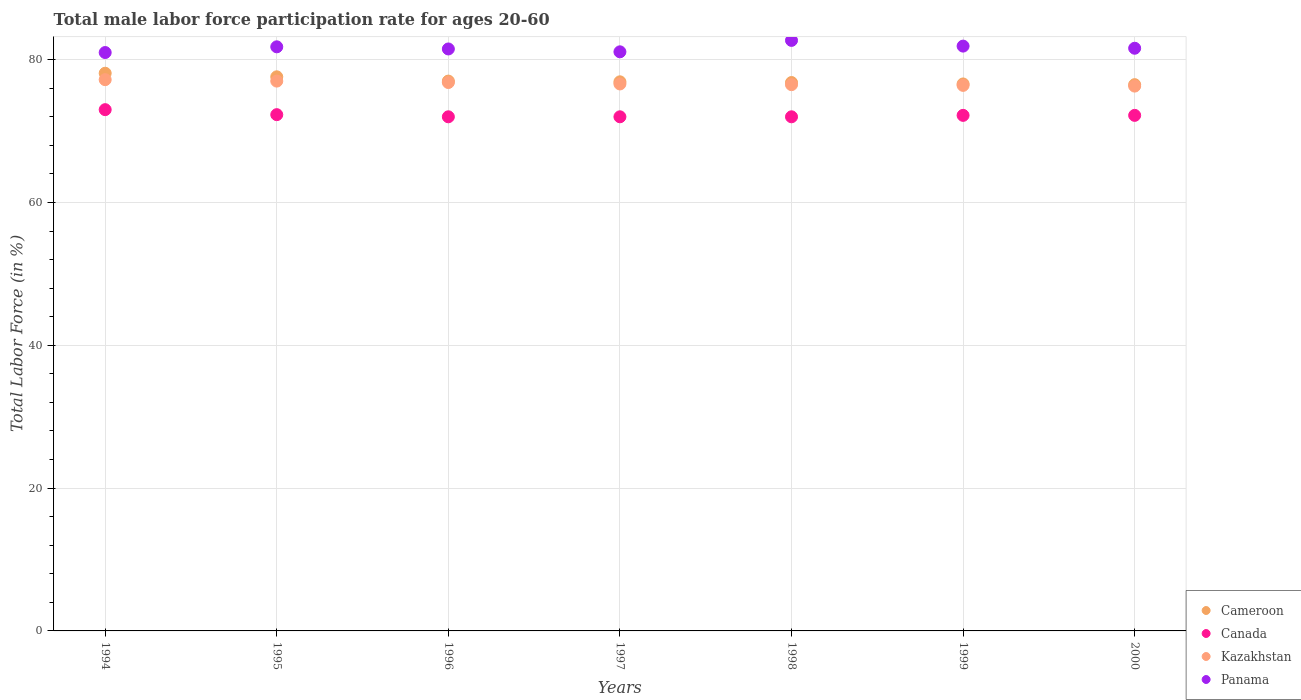How many different coloured dotlines are there?
Provide a short and direct response. 4. What is the male labor force participation rate in Kazakhstan in 1998?
Your response must be concise. 76.5. Across all years, what is the maximum male labor force participation rate in Kazakhstan?
Keep it short and to the point. 77.2. What is the total male labor force participation rate in Kazakhstan in the graph?
Make the answer very short. 536.8. What is the difference between the male labor force participation rate in Panama in 1995 and that in 1999?
Ensure brevity in your answer.  -0.1. What is the difference between the male labor force participation rate in Panama in 1999 and the male labor force participation rate in Kazakhstan in 2000?
Offer a terse response. 5.6. What is the average male labor force participation rate in Panama per year?
Give a very brief answer. 81.66. In the year 1994, what is the difference between the male labor force participation rate in Cameroon and male labor force participation rate in Kazakhstan?
Make the answer very short. 0.9. In how many years, is the male labor force participation rate in Panama greater than 72 %?
Offer a very short reply. 7. What is the ratio of the male labor force participation rate in Panama in 1998 to that in 1999?
Provide a succinct answer. 1.01. Is the male labor force participation rate in Kazakhstan in 1997 less than that in 1999?
Your answer should be compact. No. What is the difference between the highest and the lowest male labor force participation rate in Kazakhstan?
Provide a succinct answer. 0.9. Is the sum of the male labor force participation rate in Cameroon in 1998 and 2000 greater than the maximum male labor force participation rate in Kazakhstan across all years?
Your response must be concise. Yes. Is it the case that in every year, the sum of the male labor force participation rate in Kazakhstan and male labor force participation rate in Panama  is greater than the sum of male labor force participation rate in Cameroon and male labor force participation rate in Canada?
Offer a very short reply. Yes. How many years are there in the graph?
Offer a terse response. 7. What is the difference between two consecutive major ticks on the Y-axis?
Your answer should be very brief. 20. How many legend labels are there?
Offer a terse response. 4. How are the legend labels stacked?
Make the answer very short. Vertical. What is the title of the graph?
Provide a short and direct response. Total male labor force participation rate for ages 20-60. Does "Namibia" appear as one of the legend labels in the graph?
Provide a short and direct response. No. What is the label or title of the X-axis?
Provide a succinct answer. Years. What is the label or title of the Y-axis?
Provide a succinct answer. Total Labor Force (in %). What is the Total Labor Force (in %) of Cameroon in 1994?
Give a very brief answer. 78.1. What is the Total Labor Force (in %) of Canada in 1994?
Provide a succinct answer. 73. What is the Total Labor Force (in %) of Kazakhstan in 1994?
Offer a very short reply. 77.2. What is the Total Labor Force (in %) in Cameroon in 1995?
Provide a succinct answer. 77.6. What is the Total Labor Force (in %) in Canada in 1995?
Provide a short and direct response. 72.3. What is the Total Labor Force (in %) in Kazakhstan in 1995?
Keep it short and to the point. 77. What is the Total Labor Force (in %) in Panama in 1995?
Ensure brevity in your answer.  81.8. What is the Total Labor Force (in %) of Cameroon in 1996?
Your answer should be compact. 77. What is the Total Labor Force (in %) in Kazakhstan in 1996?
Your answer should be compact. 76.8. What is the Total Labor Force (in %) of Panama in 1996?
Offer a terse response. 81.5. What is the Total Labor Force (in %) of Cameroon in 1997?
Ensure brevity in your answer.  76.9. What is the Total Labor Force (in %) in Canada in 1997?
Keep it short and to the point. 72. What is the Total Labor Force (in %) in Kazakhstan in 1997?
Make the answer very short. 76.6. What is the Total Labor Force (in %) in Panama in 1997?
Offer a very short reply. 81.1. What is the Total Labor Force (in %) of Cameroon in 1998?
Your response must be concise. 76.8. What is the Total Labor Force (in %) of Kazakhstan in 1998?
Your answer should be very brief. 76.5. What is the Total Labor Force (in %) of Panama in 1998?
Keep it short and to the point. 82.7. What is the Total Labor Force (in %) in Cameroon in 1999?
Provide a short and direct response. 76.6. What is the Total Labor Force (in %) in Canada in 1999?
Make the answer very short. 72.2. What is the Total Labor Force (in %) in Kazakhstan in 1999?
Your answer should be very brief. 76.4. What is the Total Labor Force (in %) of Panama in 1999?
Give a very brief answer. 81.9. What is the Total Labor Force (in %) in Cameroon in 2000?
Your answer should be very brief. 76.5. What is the Total Labor Force (in %) in Canada in 2000?
Make the answer very short. 72.2. What is the Total Labor Force (in %) of Kazakhstan in 2000?
Your answer should be compact. 76.3. What is the Total Labor Force (in %) of Panama in 2000?
Give a very brief answer. 81.6. Across all years, what is the maximum Total Labor Force (in %) of Cameroon?
Your answer should be compact. 78.1. Across all years, what is the maximum Total Labor Force (in %) in Kazakhstan?
Offer a very short reply. 77.2. Across all years, what is the maximum Total Labor Force (in %) in Panama?
Provide a short and direct response. 82.7. Across all years, what is the minimum Total Labor Force (in %) of Cameroon?
Keep it short and to the point. 76.5. Across all years, what is the minimum Total Labor Force (in %) in Canada?
Provide a succinct answer. 72. Across all years, what is the minimum Total Labor Force (in %) of Kazakhstan?
Your answer should be very brief. 76.3. What is the total Total Labor Force (in %) of Cameroon in the graph?
Ensure brevity in your answer.  539.5. What is the total Total Labor Force (in %) in Canada in the graph?
Provide a short and direct response. 505.7. What is the total Total Labor Force (in %) in Kazakhstan in the graph?
Your answer should be very brief. 536.8. What is the total Total Labor Force (in %) in Panama in the graph?
Give a very brief answer. 571.6. What is the difference between the Total Labor Force (in %) of Cameroon in 1994 and that in 1995?
Give a very brief answer. 0.5. What is the difference between the Total Labor Force (in %) of Kazakhstan in 1994 and that in 1995?
Your response must be concise. 0.2. What is the difference between the Total Labor Force (in %) of Cameroon in 1994 and that in 1996?
Your answer should be compact. 1.1. What is the difference between the Total Labor Force (in %) in Canada in 1994 and that in 1997?
Provide a short and direct response. 1. What is the difference between the Total Labor Force (in %) in Kazakhstan in 1994 and that in 1997?
Your response must be concise. 0.6. What is the difference between the Total Labor Force (in %) of Panama in 1994 and that in 1997?
Keep it short and to the point. -0.1. What is the difference between the Total Labor Force (in %) in Canada in 1994 and that in 1998?
Your answer should be very brief. 1. What is the difference between the Total Labor Force (in %) in Kazakhstan in 1994 and that in 1998?
Your answer should be very brief. 0.7. What is the difference between the Total Labor Force (in %) of Panama in 1994 and that in 1998?
Your answer should be compact. -1.7. What is the difference between the Total Labor Force (in %) of Kazakhstan in 1994 and that in 1999?
Your answer should be very brief. 0.8. What is the difference between the Total Labor Force (in %) in Canada in 1994 and that in 2000?
Your response must be concise. 0.8. What is the difference between the Total Labor Force (in %) of Kazakhstan in 1994 and that in 2000?
Make the answer very short. 0.9. What is the difference between the Total Labor Force (in %) in Cameroon in 1995 and that in 1997?
Your response must be concise. 0.7. What is the difference between the Total Labor Force (in %) in Canada in 1995 and that in 1997?
Give a very brief answer. 0.3. What is the difference between the Total Labor Force (in %) of Kazakhstan in 1995 and that in 1997?
Your response must be concise. 0.4. What is the difference between the Total Labor Force (in %) in Panama in 1995 and that in 1997?
Your answer should be very brief. 0.7. What is the difference between the Total Labor Force (in %) in Canada in 1995 and that in 1998?
Offer a very short reply. 0.3. What is the difference between the Total Labor Force (in %) of Cameroon in 1995 and that in 1999?
Provide a succinct answer. 1. What is the difference between the Total Labor Force (in %) in Canada in 1995 and that in 1999?
Make the answer very short. 0.1. What is the difference between the Total Labor Force (in %) of Panama in 1995 and that in 1999?
Offer a very short reply. -0.1. What is the difference between the Total Labor Force (in %) of Cameroon in 1995 and that in 2000?
Give a very brief answer. 1.1. What is the difference between the Total Labor Force (in %) of Kazakhstan in 1995 and that in 2000?
Your answer should be very brief. 0.7. What is the difference between the Total Labor Force (in %) in Cameroon in 1996 and that in 1997?
Your answer should be compact. 0.1. What is the difference between the Total Labor Force (in %) of Canada in 1996 and that in 1997?
Your answer should be very brief. 0. What is the difference between the Total Labor Force (in %) of Kazakhstan in 1996 and that in 1998?
Ensure brevity in your answer.  0.3. What is the difference between the Total Labor Force (in %) in Panama in 1996 and that in 1998?
Offer a very short reply. -1.2. What is the difference between the Total Labor Force (in %) of Panama in 1996 and that in 1999?
Provide a succinct answer. -0.4. What is the difference between the Total Labor Force (in %) in Cameroon in 1996 and that in 2000?
Provide a short and direct response. 0.5. What is the difference between the Total Labor Force (in %) of Kazakhstan in 1996 and that in 2000?
Keep it short and to the point. 0.5. What is the difference between the Total Labor Force (in %) in Panama in 1996 and that in 2000?
Your answer should be compact. -0.1. What is the difference between the Total Labor Force (in %) of Kazakhstan in 1997 and that in 1998?
Keep it short and to the point. 0.1. What is the difference between the Total Labor Force (in %) in Canada in 1997 and that in 1999?
Keep it short and to the point. -0.2. What is the difference between the Total Labor Force (in %) of Panama in 1997 and that in 1999?
Keep it short and to the point. -0.8. What is the difference between the Total Labor Force (in %) in Cameroon in 1997 and that in 2000?
Offer a very short reply. 0.4. What is the difference between the Total Labor Force (in %) of Canada in 1997 and that in 2000?
Provide a short and direct response. -0.2. What is the difference between the Total Labor Force (in %) of Cameroon in 1998 and that in 1999?
Offer a very short reply. 0.2. What is the difference between the Total Labor Force (in %) of Canada in 1998 and that in 1999?
Your response must be concise. -0.2. What is the difference between the Total Labor Force (in %) in Kazakhstan in 1998 and that in 1999?
Offer a terse response. 0.1. What is the difference between the Total Labor Force (in %) of Cameroon in 1998 and that in 2000?
Give a very brief answer. 0.3. What is the difference between the Total Labor Force (in %) of Canada in 1998 and that in 2000?
Give a very brief answer. -0.2. What is the difference between the Total Labor Force (in %) of Kazakhstan in 1998 and that in 2000?
Make the answer very short. 0.2. What is the difference between the Total Labor Force (in %) in Cameroon in 1999 and that in 2000?
Provide a succinct answer. 0.1. What is the difference between the Total Labor Force (in %) in Canada in 1999 and that in 2000?
Your answer should be very brief. 0. What is the difference between the Total Labor Force (in %) of Panama in 1999 and that in 2000?
Provide a short and direct response. 0.3. What is the difference between the Total Labor Force (in %) of Cameroon in 1994 and the Total Labor Force (in %) of Canada in 1995?
Make the answer very short. 5.8. What is the difference between the Total Labor Force (in %) in Canada in 1994 and the Total Labor Force (in %) in Kazakhstan in 1995?
Make the answer very short. -4. What is the difference between the Total Labor Force (in %) of Kazakhstan in 1994 and the Total Labor Force (in %) of Panama in 1995?
Make the answer very short. -4.6. What is the difference between the Total Labor Force (in %) in Cameroon in 1994 and the Total Labor Force (in %) in Canada in 1996?
Your answer should be very brief. 6.1. What is the difference between the Total Labor Force (in %) in Cameroon in 1994 and the Total Labor Force (in %) in Kazakhstan in 1996?
Your response must be concise. 1.3. What is the difference between the Total Labor Force (in %) in Cameroon in 1994 and the Total Labor Force (in %) in Panama in 1996?
Give a very brief answer. -3.4. What is the difference between the Total Labor Force (in %) in Canada in 1994 and the Total Labor Force (in %) in Panama in 1996?
Make the answer very short. -8.5. What is the difference between the Total Labor Force (in %) in Cameroon in 1994 and the Total Labor Force (in %) in Canada in 1997?
Keep it short and to the point. 6.1. What is the difference between the Total Labor Force (in %) in Canada in 1994 and the Total Labor Force (in %) in Kazakhstan in 1997?
Your answer should be very brief. -3.6. What is the difference between the Total Labor Force (in %) of Canada in 1994 and the Total Labor Force (in %) of Panama in 1997?
Make the answer very short. -8.1. What is the difference between the Total Labor Force (in %) in Cameroon in 1994 and the Total Labor Force (in %) in Kazakhstan in 1998?
Give a very brief answer. 1.6. What is the difference between the Total Labor Force (in %) of Canada in 1994 and the Total Labor Force (in %) of Kazakhstan in 1998?
Give a very brief answer. -3.5. What is the difference between the Total Labor Force (in %) in Canada in 1994 and the Total Labor Force (in %) in Panama in 1998?
Give a very brief answer. -9.7. What is the difference between the Total Labor Force (in %) in Kazakhstan in 1994 and the Total Labor Force (in %) in Panama in 1998?
Make the answer very short. -5.5. What is the difference between the Total Labor Force (in %) in Cameroon in 1994 and the Total Labor Force (in %) in Canada in 1999?
Keep it short and to the point. 5.9. What is the difference between the Total Labor Force (in %) of Cameroon in 1994 and the Total Labor Force (in %) of Kazakhstan in 1999?
Ensure brevity in your answer.  1.7. What is the difference between the Total Labor Force (in %) in Canada in 1994 and the Total Labor Force (in %) in Kazakhstan in 1999?
Ensure brevity in your answer.  -3.4. What is the difference between the Total Labor Force (in %) in Canada in 1994 and the Total Labor Force (in %) in Panama in 1999?
Keep it short and to the point. -8.9. What is the difference between the Total Labor Force (in %) of Kazakhstan in 1994 and the Total Labor Force (in %) of Panama in 1999?
Your answer should be compact. -4.7. What is the difference between the Total Labor Force (in %) in Canada in 1994 and the Total Labor Force (in %) in Kazakhstan in 2000?
Your answer should be compact. -3.3. What is the difference between the Total Labor Force (in %) in Kazakhstan in 1994 and the Total Labor Force (in %) in Panama in 2000?
Your response must be concise. -4.4. What is the difference between the Total Labor Force (in %) in Cameroon in 1995 and the Total Labor Force (in %) in Canada in 1996?
Provide a short and direct response. 5.6. What is the difference between the Total Labor Force (in %) in Cameroon in 1995 and the Total Labor Force (in %) in Kazakhstan in 1996?
Offer a very short reply. 0.8. What is the difference between the Total Labor Force (in %) in Cameroon in 1995 and the Total Labor Force (in %) in Panama in 1996?
Make the answer very short. -3.9. What is the difference between the Total Labor Force (in %) of Canada in 1995 and the Total Labor Force (in %) of Kazakhstan in 1996?
Provide a succinct answer. -4.5. What is the difference between the Total Labor Force (in %) of Canada in 1995 and the Total Labor Force (in %) of Kazakhstan in 1997?
Ensure brevity in your answer.  -4.3. What is the difference between the Total Labor Force (in %) of Canada in 1995 and the Total Labor Force (in %) of Panama in 1997?
Provide a short and direct response. -8.8. What is the difference between the Total Labor Force (in %) of Kazakhstan in 1995 and the Total Labor Force (in %) of Panama in 1997?
Ensure brevity in your answer.  -4.1. What is the difference between the Total Labor Force (in %) of Cameroon in 1995 and the Total Labor Force (in %) of Kazakhstan in 1998?
Provide a succinct answer. 1.1. What is the difference between the Total Labor Force (in %) in Canada in 1995 and the Total Labor Force (in %) in Kazakhstan in 1998?
Provide a short and direct response. -4.2. What is the difference between the Total Labor Force (in %) in Cameroon in 1995 and the Total Labor Force (in %) in Panama in 1999?
Give a very brief answer. -4.3. What is the difference between the Total Labor Force (in %) of Cameroon in 1995 and the Total Labor Force (in %) of Canada in 2000?
Provide a short and direct response. 5.4. What is the difference between the Total Labor Force (in %) of Cameroon in 1995 and the Total Labor Force (in %) of Kazakhstan in 2000?
Offer a very short reply. 1.3. What is the difference between the Total Labor Force (in %) of Cameroon in 1995 and the Total Labor Force (in %) of Panama in 2000?
Make the answer very short. -4. What is the difference between the Total Labor Force (in %) of Canada in 1995 and the Total Labor Force (in %) of Kazakhstan in 2000?
Provide a short and direct response. -4. What is the difference between the Total Labor Force (in %) in Cameroon in 1996 and the Total Labor Force (in %) in Kazakhstan in 1997?
Offer a terse response. 0.4. What is the difference between the Total Labor Force (in %) in Canada in 1996 and the Total Labor Force (in %) in Panama in 1997?
Ensure brevity in your answer.  -9.1. What is the difference between the Total Labor Force (in %) of Cameroon in 1996 and the Total Labor Force (in %) of Kazakhstan in 1998?
Your response must be concise. 0.5. What is the difference between the Total Labor Force (in %) of Canada in 1996 and the Total Labor Force (in %) of Panama in 1998?
Make the answer very short. -10.7. What is the difference between the Total Labor Force (in %) in Cameroon in 1996 and the Total Labor Force (in %) in Kazakhstan in 1999?
Offer a terse response. 0.6. What is the difference between the Total Labor Force (in %) in Cameroon in 1996 and the Total Labor Force (in %) in Panama in 1999?
Your response must be concise. -4.9. What is the difference between the Total Labor Force (in %) of Canada in 1996 and the Total Labor Force (in %) of Kazakhstan in 1999?
Your response must be concise. -4.4. What is the difference between the Total Labor Force (in %) in Canada in 1996 and the Total Labor Force (in %) in Panama in 1999?
Your answer should be compact. -9.9. What is the difference between the Total Labor Force (in %) in Cameroon in 1996 and the Total Labor Force (in %) in Canada in 2000?
Your response must be concise. 4.8. What is the difference between the Total Labor Force (in %) in Cameroon in 1996 and the Total Labor Force (in %) in Kazakhstan in 2000?
Offer a terse response. 0.7. What is the difference between the Total Labor Force (in %) in Cameroon in 1996 and the Total Labor Force (in %) in Panama in 2000?
Make the answer very short. -4.6. What is the difference between the Total Labor Force (in %) in Canada in 1996 and the Total Labor Force (in %) in Kazakhstan in 2000?
Offer a very short reply. -4.3. What is the difference between the Total Labor Force (in %) in Kazakhstan in 1996 and the Total Labor Force (in %) in Panama in 2000?
Provide a succinct answer. -4.8. What is the difference between the Total Labor Force (in %) in Cameroon in 1997 and the Total Labor Force (in %) in Canada in 1998?
Provide a succinct answer. 4.9. What is the difference between the Total Labor Force (in %) in Cameroon in 1997 and the Total Labor Force (in %) in Kazakhstan in 1998?
Your response must be concise. 0.4. What is the difference between the Total Labor Force (in %) in Cameroon in 1997 and the Total Labor Force (in %) in Panama in 1998?
Make the answer very short. -5.8. What is the difference between the Total Labor Force (in %) of Cameroon in 1997 and the Total Labor Force (in %) of Canada in 2000?
Your response must be concise. 4.7. What is the difference between the Total Labor Force (in %) in Canada in 1997 and the Total Labor Force (in %) in Panama in 2000?
Offer a terse response. -9.6. What is the difference between the Total Labor Force (in %) in Kazakhstan in 1997 and the Total Labor Force (in %) in Panama in 2000?
Provide a succinct answer. -5. What is the difference between the Total Labor Force (in %) in Cameroon in 1998 and the Total Labor Force (in %) in Canada in 1999?
Provide a short and direct response. 4.6. What is the difference between the Total Labor Force (in %) of Cameroon in 1998 and the Total Labor Force (in %) of Kazakhstan in 1999?
Offer a terse response. 0.4. What is the difference between the Total Labor Force (in %) in Cameroon in 1998 and the Total Labor Force (in %) in Canada in 2000?
Give a very brief answer. 4.6. What is the difference between the Total Labor Force (in %) of Canada in 1998 and the Total Labor Force (in %) of Kazakhstan in 2000?
Offer a terse response. -4.3. What is the difference between the Total Labor Force (in %) in Canada in 1998 and the Total Labor Force (in %) in Panama in 2000?
Offer a very short reply. -9.6. What is the difference between the Total Labor Force (in %) of Cameroon in 1999 and the Total Labor Force (in %) of Kazakhstan in 2000?
Keep it short and to the point. 0.3. What is the difference between the Total Labor Force (in %) in Canada in 1999 and the Total Labor Force (in %) in Kazakhstan in 2000?
Give a very brief answer. -4.1. What is the difference between the Total Labor Force (in %) of Canada in 1999 and the Total Labor Force (in %) of Panama in 2000?
Your answer should be very brief. -9.4. What is the average Total Labor Force (in %) of Cameroon per year?
Your answer should be compact. 77.07. What is the average Total Labor Force (in %) of Canada per year?
Your answer should be very brief. 72.24. What is the average Total Labor Force (in %) in Kazakhstan per year?
Offer a very short reply. 76.69. What is the average Total Labor Force (in %) in Panama per year?
Keep it short and to the point. 81.66. In the year 1994, what is the difference between the Total Labor Force (in %) in Cameroon and Total Labor Force (in %) in Canada?
Offer a very short reply. 5.1. In the year 1994, what is the difference between the Total Labor Force (in %) in Cameroon and Total Labor Force (in %) in Kazakhstan?
Provide a short and direct response. 0.9. In the year 1994, what is the difference between the Total Labor Force (in %) of Cameroon and Total Labor Force (in %) of Panama?
Provide a short and direct response. -2.9. In the year 1994, what is the difference between the Total Labor Force (in %) of Canada and Total Labor Force (in %) of Kazakhstan?
Offer a very short reply. -4.2. In the year 1994, what is the difference between the Total Labor Force (in %) in Canada and Total Labor Force (in %) in Panama?
Provide a succinct answer. -8. In the year 1995, what is the difference between the Total Labor Force (in %) in Cameroon and Total Labor Force (in %) in Canada?
Give a very brief answer. 5.3. In the year 1995, what is the difference between the Total Labor Force (in %) of Cameroon and Total Labor Force (in %) of Kazakhstan?
Provide a succinct answer. 0.6. In the year 1995, what is the difference between the Total Labor Force (in %) of Cameroon and Total Labor Force (in %) of Panama?
Keep it short and to the point. -4.2. In the year 1995, what is the difference between the Total Labor Force (in %) in Canada and Total Labor Force (in %) in Panama?
Keep it short and to the point. -9.5. In the year 1995, what is the difference between the Total Labor Force (in %) in Kazakhstan and Total Labor Force (in %) in Panama?
Offer a terse response. -4.8. In the year 1996, what is the difference between the Total Labor Force (in %) in Canada and Total Labor Force (in %) in Kazakhstan?
Give a very brief answer. -4.8. In the year 1996, what is the difference between the Total Labor Force (in %) of Kazakhstan and Total Labor Force (in %) of Panama?
Provide a succinct answer. -4.7. In the year 1997, what is the difference between the Total Labor Force (in %) of Cameroon and Total Labor Force (in %) of Canada?
Ensure brevity in your answer.  4.9. In the year 1997, what is the difference between the Total Labor Force (in %) in Cameroon and Total Labor Force (in %) in Panama?
Keep it short and to the point. -4.2. In the year 1998, what is the difference between the Total Labor Force (in %) of Cameroon and Total Labor Force (in %) of Canada?
Provide a succinct answer. 4.8. In the year 1998, what is the difference between the Total Labor Force (in %) of Cameroon and Total Labor Force (in %) of Panama?
Your answer should be very brief. -5.9. In the year 1998, what is the difference between the Total Labor Force (in %) in Canada and Total Labor Force (in %) in Panama?
Your response must be concise. -10.7. In the year 1998, what is the difference between the Total Labor Force (in %) of Kazakhstan and Total Labor Force (in %) of Panama?
Offer a terse response. -6.2. In the year 1999, what is the difference between the Total Labor Force (in %) in Cameroon and Total Labor Force (in %) in Kazakhstan?
Offer a very short reply. 0.2. In the year 1999, what is the difference between the Total Labor Force (in %) of Kazakhstan and Total Labor Force (in %) of Panama?
Ensure brevity in your answer.  -5.5. In the year 2000, what is the difference between the Total Labor Force (in %) of Cameroon and Total Labor Force (in %) of Canada?
Make the answer very short. 4.3. In the year 2000, what is the difference between the Total Labor Force (in %) in Canada and Total Labor Force (in %) in Kazakhstan?
Offer a very short reply. -4.1. In the year 2000, what is the difference between the Total Labor Force (in %) of Kazakhstan and Total Labor Force (in %) of Panama?
Give a very brief answer. -5.3. What is the ratio of the Total Labor Force (in %) of Cameroon in 1994 to that in 1995?
Your answer should be very brief. 1.01. What is the ratio of the Total Labor Force (in %) of Canada in 1994 to that in 1995?
Offer a very short reply. 1.01. What is the ratio of the Total Labor Force (in %) of Panama in 1994 to that in 1995?
Make the answer very short. 0.99. What is the ratio of the Total Labor Force (in %) of Cameroon in 1994 to that in 1996?
Your response must be concise. 1.01. What is the ratio of the Total Labor Force (in %) in Canada in 1994 to that in 1996?
Your answer should be compact. 1.01. What is the ratio of the Total Labor Force (in %) in Kazakhstan in 1994 to that in 1996?
Make the answer very short. 1.01. What is the ratio of the Total Labor Force (in %) in Cameroon in 1994 to that in 1997?
Give a very brief answer. 1.02. What is the ratio of the Total Labor Force (in %) of Canada in 1994 to that in 1997?
Give a very brief answer. 1.01. What is the ratio of the Total Labor Force (in %) in Kazakhstan in 1994 to that in 1997?
Provide a short and direct response. 1.01. What is the ratio of the Total Labor Force (in %) in Cameroon in 1994 to that in 1998?
Offer a very short reply. 1.02. What is the ratio of the Total Labor Force (in %) in Canada in 1994 to that in 1998?
Give a very brief answer. 1.01. What is the ratio of the Total Labor Force (in %) of Kazakhstan in 1994 to that in 1998?
Your answer should be compact. 1.01. What is the ratio of the Total Labor Force (in %) of Panama in 1994 to that in 1998?
Give a very brief answer. 0.98. What is the ratio of the Total Labor Force (in %) in Cameroon in 1994 to that in 1999?
Offer a very short reply. 1.02. What is the ratio of the Total Labor Force (in %) of Canada in 1994 to that in 1999?
Make the answer very short. 1.01. What is the ratio of the Total Labor Force (in %) in Kazakhstan in 1994 to that in 1999?
Offer a terse response. 1.01. What is the ratio of the Total Labor Force (in %) of Panama in 1994 to that in 1999?
Offer a terse response. 0.99. What is the ratio of the Total Labor Force (in %) of Cameroon in 1994 to that in 2000?
Your answer should be compact. 1.02. What is the ratio of the Total Labor Force (in %) of Canada in 1994 to that in 2000?
Your answer should be compact. 1.01. What is the ratio of the Total Labor Force (in %) in Kazakhstan in 1994 to that in 2000?
Ensure brevity in your answer.  1.01. What is the ratio of the Total Labor Force (in %) in Panama in 1994 to that in 2000?
Your answer should be very brief. 0.99. What is the ratio of the Total Labor Force (in %) of Panama in 1995 to that in 1996?
Make the answer very short. 1. What is the ratio of the Total Labor Force (in %) in Cameroon in 1995 to that in 1997?
Your answer should be compact. 1.01. What is the ratio of the Total Labor Force (in %) in Canada in 1995 to that in 1997?
Provide a succinct answer. 1. What is the ratio of the Total Labor Force (in %) in Kazakhstan in 1995 to that in 1997?
Make the answer very short. 1.01. What is the ratio of the Total Labor Force (in %) of Panama in 1995 to that in 1997?
Offer a terse response. 1.01. What is the ratio of the Total Labor Force (in %) of Cameroon in 1995 to that in 1998?
Provide a short and direct response. 1.01. What is the ratio of the Total Labor Force (in %) of Canada in 1995 to that in 1998?
Your response must be concise. 1. What is the ratio of the Total Labor Force (in %) of Kazakhstan in 1995 to that in 1998?
Ensure brevity in your answer.  1.01. What is the ratio of the Total Labor Force (in %) in Cameroon in 1995 to that in 1999?
Offer a terse response. 1.01. What is the ratio of the Total Labor Force (in %) of Kazakhstan in 1995 to that in 1999?
Give a very brief answer. 1.01. What is the ratio of the Total Labor Force (in %) of Cameroon in 1995 to that in 2000?
Offer a very short reply. 1.01. What is the ratio of the Total Labor Force (in %) in Canada in 1995 to that in 2000?
Offer a terse response. 1. What is the ratio of the Total Labor Force (in %) in Kazakhstan in 1995 to that in 2000?
Offer a very short reply. 1.01. What is the ratio of the Total Labor Force (in %) in Panama in 1995 to that in 2000?
Your answer should be compact. 1. What is the ratio of the Total Labor Force (in %) of Cameroon in 1996 to that in 1997?
Provide a short and direct response. 1. What is the ratio of the Total Labor Force (in %) of Kazakhstan in 1996 to that in 1997?
Make the answer very short. 1. What is the ratio of the Total Labor Force (in %) of Panama in 1996 to that in 1997?
Your answer should be very brief. 1. What is the ratio of the Total Labor Force (in %) of Canada in 1996 to that in 1998?
Keep it short and to the point. 1. What is the ratio of the Total Labor Force (in %) in Kazakhstan in 1996 to that in 1998?
Give a very brief answer. 1. What is the ratio of the Total Labor Force (in %) of Panama in 1996 to that in 1998?
Make the answer very short. 0.99. What is the ratio of the Total Labor Force (in %) of Kazakhstan in 1996 to that in 1999?
Offer a very short reply. 1.01. What is the ratio of the Total Labor Force (in %) in Panama in 1996 to that in 1999?
Offer a terse response. 1. What is the ratio of the Total Labor Force (in %) of Cameroon in 1996 to that in 2000?
Your answer should be very brief. 1.01. What is the ratio of the Total Labor Force (in %) of Canada in 1996 to that in 2000?
Your response must be concise. 1. What is the ratio of the Total Labor Force (in %) of Kazakhstan in 1996 to that in 2000?
Give a very brief answer. 1.01. What is the ratio of the Total Labor Force (in %) in Canada in 1997 to that in 1998?
Your answer should be very brief. 1. What is the ratio of the Total Labor Force (in %) in Kazakhstan in 1997 to that in 1998?
Your answer should be compact. 1. What is the ratio of the Total Labor Force (in %) in Panama in 1997 to that in 1998?
Make the answer very short. 0.98. What is the ratio of the Total Labor Force (in %) of Cameroon in 1997 to that in 1999?
Provide a succinct answer. 1. What is the ratio of the Total Labor Force (in %) in Canada in 1997 to that in 1999?
Make the answer very short. 1. What is the ratio of the Total Labor Force (in %) in Panama in 1997 to that in 1999?
Offer a very short reply. 0.99. What is the ratio of the Total Labor Force (in %) of Cameroon in 1997 to that in 2000?
Provide a short and direct response. 1.01. What is the ratio of the Total Labor Force (in %) in Kazakhstan in 1997 to that in 2000?
Your response must be concise. 1. What is the ratio of the Total Labor Force (in %) of Panama in 1997 to that in 2000?
Provide a succinct answer. 0.99. What is the ratio of the Total Labor Force (in %) of Cameroon in 1998 to that in 1999?
Ensure brevity in your answer.  1. What is the ratio of the Total Labor Force (in %) in Panama in 1998 to that in 1999?
Your response must be concise. 1.01. What is the ratio of the Total Labor Force (in %) in Panama in 1998 to that in 2000?
Provide a succinct answer. 1.01. What is the ratio of the Total Labor Force (in %) in Cameroon in 1999 to that in 2000?
Keep it short and to the point. 1. What is the difference between the highest and the second highest Total Labor Force (in %) of Canada?
Ensure brevity in your answer.  0.7. What is the difference between the highest and the second highest Total Labor Force (in %) of Kazakhstan?
Your response must be concise. 0.2. What is the difference between the highest and the lowest Total Labor Force (in %) of Cameroon?
Make the answer very short. 1.6. What is the difference between the highest and the lowest Total Labor Force (in %) of Kazakhstan?
Ensure brevity in your answer.  0.9. 